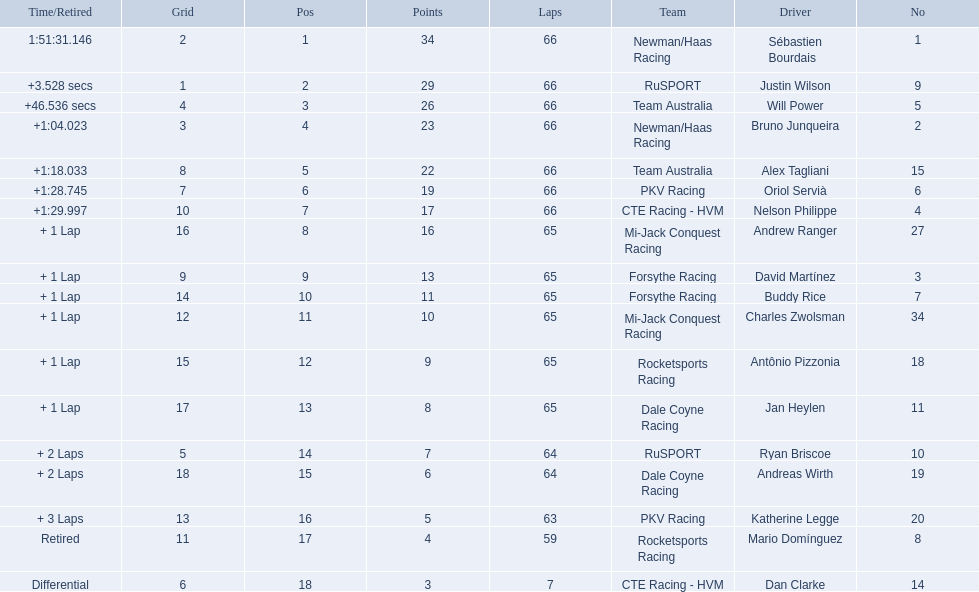How many points did first place receive? 34. How many did last place receive? 3. Who was the recipient of these last place points? Dan Clarke. 